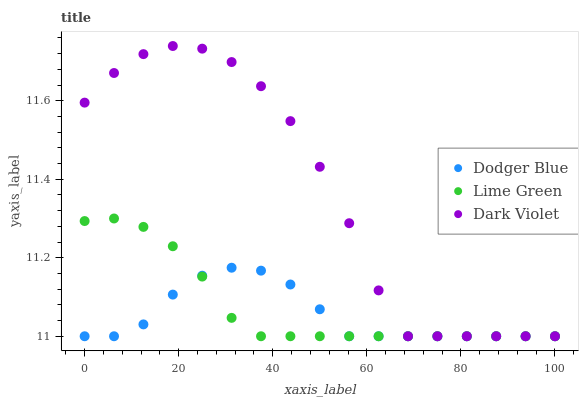Does Dodger Blue have the minimum area under the curve?
Answer yes or no. Yes. Does Dark Violet have the maximum area under the curve?
Answer yes or no. Yes. Does Dark Violet have the minimum area under the curve?
Answer yes or no. No. Does Dodger Blue have the maximum area under the curve?
Answer yes or no. No. Is Lime Green the smoothest?
Answer yes or no. Yes. Is Dark Violet the roughest?
Answer yes or no. Yes. Is Dodger Blue the smoothest?
Answer yes or no. No. Is Dodger Blue the roughest?
Answer yes or no. No. Does Lime Green have the lowest value?
Answer yes or no. Yes. Does Dark Violet have the highest value?
Answer yes or no. Yes. Does Dodger Blue have the highest value?
Answer yes or no. No. Does Lime Green intersect Dodger Blue?
Answer yes or no. Yes. Is Lime Green less than Dodger Blue?
Answer yes or no. No. Is Lime Green greater than Dodger Blue?
Answer yes or no. No. 